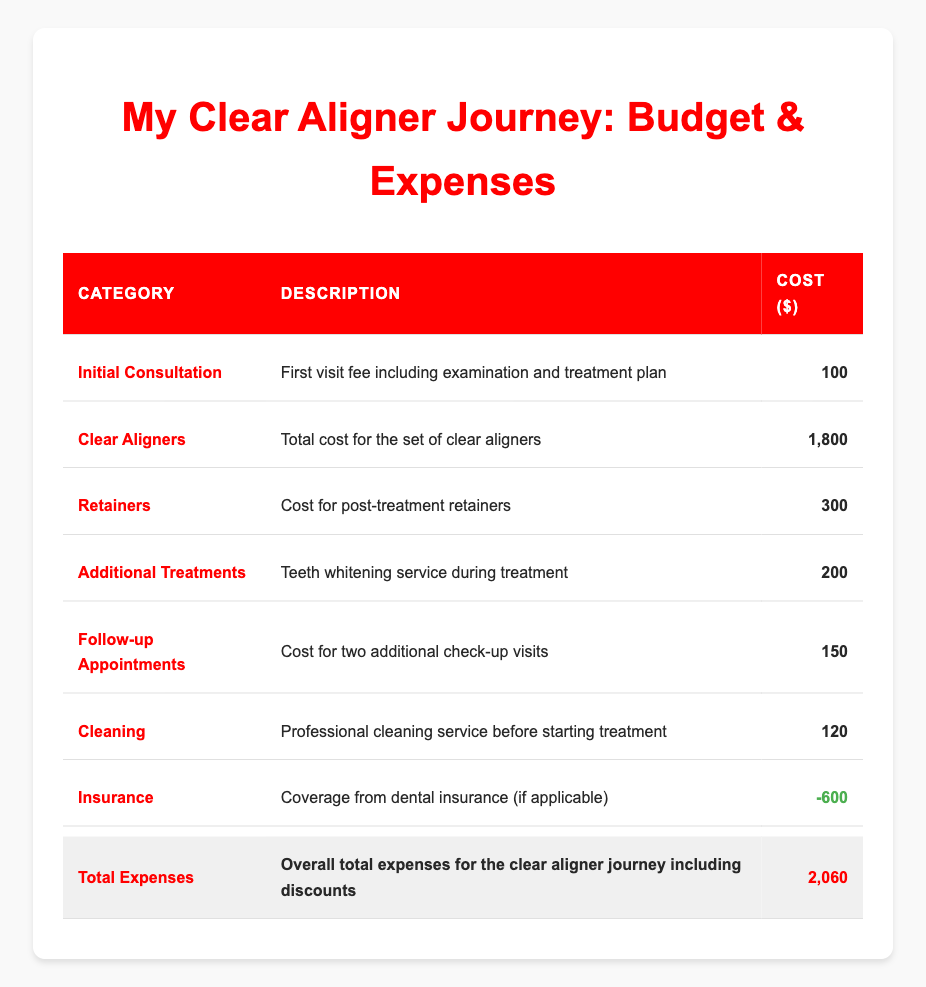What is the cost of the Initial Consultation? The cost for the Initial Consultation is listed under the "Cost" column for that category, which is 100.
Answer: 100 What is the total cost for the Clear Aligners? The cost for the Clear Aligners section is indicated as 1,800 in the "Cost" column.
Answer: 1800 How much do the Retainers cost? The Retainers cost is explicitly shown in the "Cost" column under that category, which is 300.
Answer: 300 What are the total expenses for the clear aligner journey? The total expenses are recorded in the last row of the table under "Total Expenses," which shows a value of 2,060.
Answer: 2060 Is the insurance cost reported as a positive or negative number? The insurance cost is shown as -600, indicating it is reported as a negative number.
Answer: Negative What is the total additional cost incurred for the Follow-up Appointments and Additional Treatments? The cost for Follow-up Appointments is 150 and for Additional Treatments is 200. Adding these two gives 150 + 200 = 350.
Answer: 350 If I subtract the insurance coverage from the total expenses, what would the result be? The total expenses are 2,060 and the insurance coverage is -600. To subtract the insurance coverage, we calculate 2,060 - (-600), which is 2,060 + 600 = 2,660.
Answer: 2660 What percentage of the total expenses does the cost of Clear Aligners represent? The cost of Clear Aligners is 1,800 and the total expenses are 2,060. To find the percentage, we calculate (1,800 / 2,060) * 100, which is approximately 87.79%.
Answer: 87.79% Were Follow-up Appointments more expensive than the Initial Consultation? The cost for Follow-up Appointments is 150, and the cost for the Initial Consultation is 100. Since 150 is greater than 100, the statement is true.
Answer: Yes 